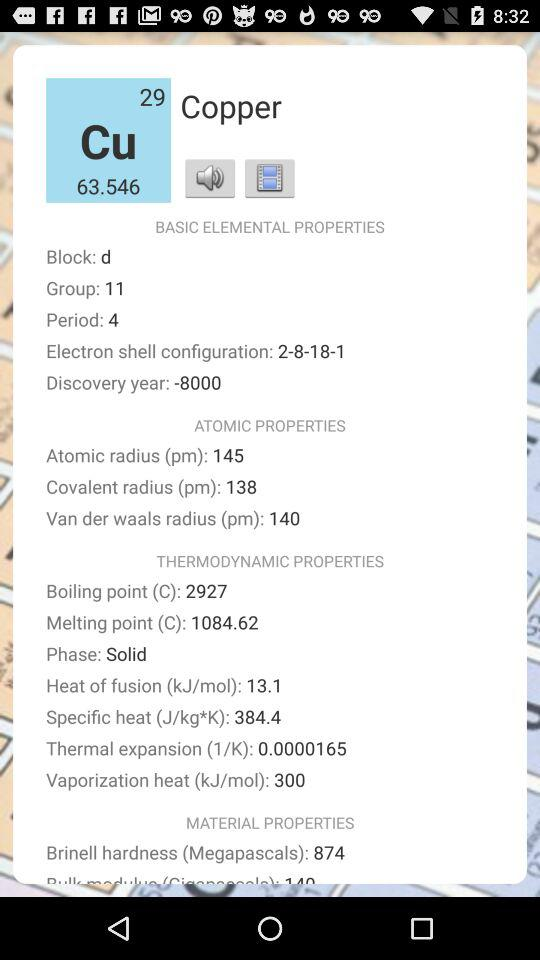What is the difference between the atomic radius and the covalent radius of copper?
Answer the question using a single word or phrase. 7 